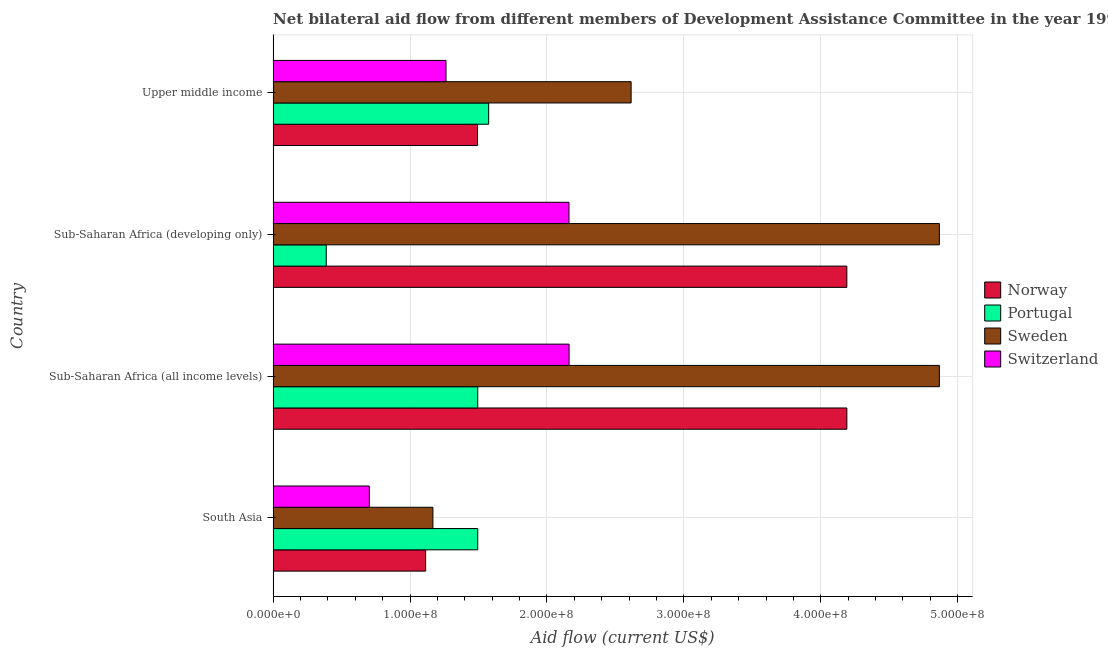Are the number of bars per tick equal to the number of legend labels?
Keep it short and to the point. Yes. What is the label of the 1st group of bars from the top?
Provide a short and direct response. Upper middle income. In how many cases, is the number of bars for a given country not equal to the number of legend labels?
Your answer should be compact. 0. What is the amount of aid given by norway in Sub-Saharan Africa (developing only)?
Keep it short and to the point. 4.19e+08. Across all countries, what is the maximum amount of aid given by sweden?
Your response must be concise. 4.87e+08. Across all countries, what is the minimum amount of aid given by norway?
Give a very brief answer. 1.11e+08. In which country was the amount of aid given by portugal maximum?
Provide a short and direct response. Upper middle income. In which country was the amount of aid given by sweden minimum?
Offer a very short reply. South Asia. What is the total amount of aid given by sweden in the graph?
Provide a short and direct response. 1.35e+09. What is the difference between the amount of aid given by switzerland in Sub-Saharan Africa (all income levels) and the amount of aid given by sweden in Upper middle income?
Offer a very short reply. -4.53e+07. What is the average amount of aid given by norway per country?
Provide a succinct answer. 2.75e+08. What is the difference between the amount of aid given by portugal and amount of aid given by norway in Sub-Saharan Africa (developing only)?
Your answer should be very brief. -3.80e+08. What is the ratio of the amount of aid given by sweden in South Asia to that in Upper middle income?
Offer a terse response. 0.45. Is the difference between the amount of aid given by switzerland in South Asia and Upper middle income greater than the difference between the amount of aid given by norway in South Asia and Upper middle income?
Offer a very short reply. No. What is the difference between the highest and the lowest amount of aid given by switzerland?
Your response must be concise. 1.46e+08. In how many countries, is the amount of aid given by switzerland greater than the average amount of aid given by switzerland taken over all countries?
Provide a short and direct response. 2. Is the sum of the amount of aid given by norway in Sub-Saharan Africa (all income levels) and Sub-Saharan Africa (developing only) greater than the maximum amount of aid given by switzerland across all countries?
Your answer should be very brief. Yes. How many countries are there in the graph?
Provide a short and direct response. 4. Are the values on the major ticks of X-axis written in scientific E-notation?
Provide a short and direct response. Yes. Does the graph contain any zero values?
Offer a very short reply. No. Does the graph contain grids?
Give a very brief answer. Yes. Where does the legend appear in the graph?
Offer a very short reply. Center right. What is the title of the graph?
Make the answer very short. Net bilateral aid flow from different members of Development Assistance Committee in the year 1996. What is the label or title of the Y-axis?
Give a very brief answer. Country. What is the Aid flow (current US$) of Norway in South Asia?
Keep it short and to the point. 1.11e+08. What is the Aid flow (current US$) in Portugal in South Asia?
Make the answer very short. 1.49e+08. What is the Aid flow (current US$) in Sweden in South Asia?
Keep it short and to the point. 1.17e+08. What is the Aid flow (current US$) of Switzerland in South Asia?
Your response must be concise. 7.03e+07. What is the Aid flow (current US$) in Norway in Sub-Saharan Africa (all income levels)?
Offer a very short reply. 4.19e+08. What is the Aid flow (current US$) of Portugal in Sub-Saharan Africa (all income levels)?
Your response must be concise. 1.49e+08. What is the Aid flow (current US$) in Sweden in Sub-Saharan Africa (all income levels)?
Your answer should be compact. 4.87e+08. What is the Aid flow (current US$) of Switzerland in Sub-Saharan Africa (all income levels)?
Keep it short and to the point. 2.16e+08. What is the Aid flow (current US$) of Norway in Sub-Saharan Africa (developing only)?
Provide a short and direct response. 4.19e+08. What is the Aid flow (current US$) in Portugal in Sub-Saharan Africa (developing only)?
Give a very brief answer. 3.88e+07. What is the Aid flow (current US$) of Sweden in Sub-Saharan Africa (developing only)?
Make the answer very short. 4.87e+08. What is the Aid flow (current US$) of Switzerland in Sub-Saharan Africa (developing only)?
Ensure brevity in your answer.  2.16e+08. What is the Aid flow (current US$) in Norway in Upper middle income?
Give a very brief answer. 1.49e+08. What is the Aid flow (current US$) of Portugal in Upper middle income?
Give a very brief answer. 1.57e+08. What is the Aid flow (current US$) in Sweden in Upper middle income?
Your answer should be compact. 2.61e+08. What is the Aid flow (current US$) of Switzerland in Upper middle income?
Give a very brief answer. 1.26e+08. Across all countries, what is the maximum Aid flow (current US$) of Norway?
Give a very brief answer. 4.19e+08. Across all countries, what is the maximum Aid flow (current US$) in Portugal?
Offer a terse response. 1.57e+08. Across all countries, what is the maximum Aid flow (current US$) of Sweden?
Keep it short and to the point. 4.87e+08. Across all countries, what is the maximum Aid flow (current US$) of Switzerland?
Offer a terse response. 2.16e+08. Across all countries, what is the minimum Aid flow (current US$) in Norway?
Provide a short and direct response. 1.11e+08. Across all countries, what is the minimum Aid flow (current US$) in Portugal?
Offer a very short reply. 3.88e+07. Across all countries, what is the minimum Aid flow (current US$) in Sweden?
Make the answer very short. 1.17e+08. Across all countries, what is the minimum Aid flow (current US$) in Switzerland?
Provide a short and direct response. 7.03e+07. What is the total Aid flow (current US$) of Norway in the graph?
Offer a terse response. 1.10e+09. What is the total Aid flow (current US$) in Portugal in the graph?
Keep it short and to the point. 4.95e+08. What is the total Aid flow (current US$) in Sweden in the graph?
Keep it short and to the point. 1.35e+09. What is the total Aid flow (current US$) of Switzerland in the graph?
Your response must be concise. 6.29e+08. What is the difference between the Aid flow (current US$) of Norway in South Asia and that in Sub-Saharan Africa (all income levels)?
Your answer should be compact. -3.08e+08. What is the difference between the Aid flow (current US$) of Sweden in South Asia and that in Sub-Saharan Africa (all income levels)?
Offer a terse response. -3.70e+08. What is the difference between the Aid flow (current US$) in Switzerland in South Asia and that in Sub-Saharan Africa (all income levels)?
Offer a very short reply. -1.46e+08. What is the difference between the Aid flow (current US$) in Norway in South Asia and that in Sub-Saharan Africa (developing only)?
Your response must be concise. -3.08e+08. What is the difference between the Aid flow (current US$) in Portugal in South Asia and that in Sub-Saharan Africa (developing only)?
Keep it short and to the point. 1.11e+08. What is the difference between the Aid flow (current US$) in Sweden in South Asia and that in Sub-Saharan Africa (developing only)?
Keep it short and to the point. -3.70e+08. What is the difference between the Aid flow (current US$) in Switzerland in South Asia and that in Sub-Saharan Africa (developing only)?
Provide a succinct answer. -1.46e+08. What is the difference between the Aid flow (current US$) of Norway in South Asia and that in Upper middle income?
Make the answer very short. -3.79e+07. What is the difference between the Aid flow (current US$) of Portugal in South Asia and that in Upper middle income?
Your answer should be very brief. -7.98e+06. What is the difference between the Aid flow (current US$) in Sweden in South Asia and that in Upper middle income?
Ensure brevity in your answer.  -1.45e+08. What is the difference between the Aid flow (current US$) of Switzerland in South Asia and that in Upper middle income?
Your answer should be compact. -5.60e+07. What is the difference between the Aid flow (current US$) in Norway in Sub-Saharan Africa (all income levels) and that in Sub-Saharan Africa (developing only)?
Provide a succinct answer. 10000. What is the difference between the Aid flow (current US$) in Portugal in Sub-Saharan Africa (all income levels) and that in Sub-Saharan Africa (developing only)?
Provide a succinct answer. 1.11e+08. What is the difference between the Aid flow (current US$) of Norway in Sub-Saharan Africa (all income levels) and that in Upper middle income?
Your answer should be compact. 2.70e+08. What is the difference between the Aid flow (current US$) of Portugal in Sub-Saharan Africa (all income levels) and that in Upper middle income?
Ensure brevity in your answer.  -7.98e+06. What is the difference between the Aid flow (current US$) in Sweden in Sub-Saharan Africa (all income levels) and that in Upper middle income?
Your response must be concise. 2.25e+08. What is the difference between the Aid flow (current US$) in Switzerland in Sub-Saharan Africa (all income levels) and that in Upper middle income?
Provide a succinct answer. 8.99e+07. What is the difference between the Aid flow (current US$) in Norway in Sub-Saharan Africa (developing only) and that in Upper middle income?
Offer a very short reply. 2.70e+08. What is the difference between the Aid flow (current US$) in Portugal in Sub-Saharan Africa (developing only) and that in Upper middle income?
Your answer should be compact. -1.19e+08. What is the difference between the Aid flow (current US$) of Sweden in Sub-Saharan Africa (developing only) and that in Upper middle income?
Provide a succinct answer. 2.25e+08. What is the difference between the Aid flow (current US$) of Switzerland in Sub-Saharan Africa (developing only) and that in Upper middle income?
Give a very brief answer. 8.98e+07. What is the difference between the Aid flow (current US$) in Norway in South Asia and the Aid flow (current US$) in Portugal in Sub-Saharan Africa (all income levels)?
Your answer should be compact. -3.81e+07. What is the difference between the Aid flow (current US$) in Norway in South Asia and the Aid flow (current US$) in Sweden in Sub-Saharan Africa (all income levels)?
Your response must be concise. -3.75e+08. What is the difference between the Aid flow (current US$) in Norway in South Asia and the Aid flow (current US$) in Switzerland in Sub-Saharan Africa (all income levels)?
Make the answer very short. -1.05e+08. What is the difference between the Aid flow (current US$) of Portugal in South Asia and the Aid flow (current US$) of Sweden in Sub-Saharan Africa (all income levels)?
Ensure brevity in your answer.  -3.37e+08. What is the difference between the Aid flow (current US$) of Portugal in South Asia and the Aid flow (current US$) of Switzerland in Sub-Saharan Africa (all income levels)?
Your answer should be very brief. -6.67e+07. What is the difference between the Aid flow (current US$) in Sweden in South Asia and the Aid flow (current US$) in Switzerland in Sub-Saharan Africa (all income levels)?
Provide a succinct answer. -9.95e+07. What is the difference between the Aid flow (current US$) of Norway in South Asia and the Aid flow (current US$) of Portugal in Sub-Saharan Africa (developing only)?
Ensure brevity in your answer.  7.26e+07. What is the difference between the Aid flow (current US$) of Norway in South Asia and the Aid flow (current US$) of Sweden in Sub-Saharan Africa (developing only)?
Your answer should be compact. -3.75e+08. What is the difference between the Aid flow (current US$) in Norway in South Asia and the Aid flow (current US$) in Switzerland in Sub-Saharan Africa (developing only)?
Offer a terse response. -1.05e+08. What is the difference between the Aid flow (current US$) of Portugal in South Asia and the Aid flow (current US$) of Sweden in Sub-Saharan Africa (developing only)?
Your answer should be compact. -3.37e+08. What is the difference between the Aid flow (current US$) of Portugal in South Asia and the Aid flow (current US$) of Switzerland in Sub-Saharan Africa (developing only)?
Offer a terse response. -6.66e+07. What is the difference between the Aid flow (current US$) in Sweden in South Asia and the Aid flow (current US$) in Switzerland in Sub-Saharan Africa (developing only)?
Offer a terse response. -9.94e+07. What is the difference between the Aid flow (current US$) in Norway in South Asia and the Aid flow (current US$) in Portugal in Upper middle income?
Make the answer very short. -4.60e+07. What is the difference between the Aid flow (current US$) in Norway in South Asia and the Aid flow (current US$) in Sweden in Upper middle income?
Offer a terse response. -1.50e+08. What is the difference between the Aid flow (current US$) in Norway in South Asia and the Aid flow (current US$) in Switzerland in Upper middle income?
Offer a very short reply. -1.49e+07. What is the difference between the Aid flow (current US$) in Portugal in South Asia and the Aid flow (current US$) in Sweden in Upper middle income?
Ensure brevity in your answer.  -1.12e+08. What is the difference between the Aid flow (current US$) in Portugal in South Asia and the Aid flow (current US$) in Switzerland in Upper middle income?
Offer a very short reply. 2.32e+07. What is the difference between the Aid flow (current US$) of Sweden in South Asia and the Aid flow (current US$) of Switzerland in Upper middle income?
Your answer should be compact. -9.58e+06. What is the difference between the Aid flow (current US$) in Norway in Sub-Saharan Africa (all income levels) and the Aid flow (current US$) in Portugal in Sub-Saharan Africa (developing only)?
Give a very brief answer. 3.80e+08. What is the difference between the Aid flow (current US$) in Norway in Sub-Saharan Africa (all income levels) and the Aid flow (current US$) in Sweden in Sub-Saharan Africa (developing only)?
Ensure brevity in your answer.  -6.76e+07. What is the difference between the Aid flow (current US$) of Norway in Sub-Saharan Africa (all income levels) and the Aid flow (current US$) of Switzerland in Sub-Saharan Africa (developing only)?
Your answer should be compact. 2.03e+08. What is the difference between the Aid flow (current US$) in Portugal in Sub-Saharan Africa (all income levels) and the Aid flow (current US$) in Sweden in Sub-Saharan Africa (developing only)?
Make the answer very short. -3.37e+08. What is the difference between the Aid flow (current US$) of Portugal in Sub-Saharan Africa (all income levels) and the Aid flow (current US$) of Switzerland in Sub-Saharan Africa (developing only)?
Your response must be concise. -6.66e+07. What is the difference between the Aid flow (current US$) of Sweden in Sub-Saharan Africa (all income levels) and the Aid flow (current US$) of Switzerland in Sub-Saharan Africa (developing only)?
Make the answer very short. 2.71e+08. What is the difference between the Aid flow (current US$) of Norway in Sub-Saharan Africa (all income levels) and the Aid flow (current US$) of Portugal in Upper middle income?
Your answer should be very brief. 2.62e+08. What is the difference between the Aid flow (current US$) of Norway in Sub-Saharan Africa (all income levels) and the Aid flow (current US$) of Sweden in Upper middle income?
Ensure brevity in your answer.  1.58e+08. What is the difference between the Aid flow (current US$) in Norway in Sub-Saharan Africa (all income levels) and the Aid flow (current US$) in Switzerland in Upper middle income?
Provide a succinct answer. 2.93e+08. What is the difference between the Aid flow (current US$) of Portugal in Sub-Saharan Africa (all income levels) and the Aid flow (current US$) of Sweden in Upper middle income?
Provide a short and direct response. -1.12e+08. What is the difference between the Aid flow (current US$) of Portugal in Sub-Saharan Africa (all income levels) and the Aid flow (current US$) of Switzerland in Upper middle income?
Your answer should be compact. 2.32e+07. What is the difference between the Aid flow (current US$) in Sweden in Sub-Saharan Africa (all income levels) and the Aid flow (current US$) in Switzerland in Upper middle income?
Offer a terse response. 3.60e+08. What is the difference between the Aid flow (current US$) in Norway in Sub-Saharan Africa (developing only) and the Aid flow (current US$) in Portugal in Upper middle income?
Offer a very short reply. 2.62e+08. What is the difference between the Aid flow (current US$) in Norway in Sub-Saharan Africa (developing only) and the Aid flow (current US$) in Sweden in Upper middle income?
Your response must be concise. 1.58e+08. What is the difference between the Aid flow (current US$) in Norway in Sub-Saharan Africa (developing only) and the Aid flow (current US$) in Switzerland in Upper middle income?
Keep it short and to the point. 2.93e+08. What is the difference between the Aid flow (current US$) of Portugal in Sub-Saharan Africa (developing only) and the Aid flow (current US$) of Sweden in Upper middle income?
Provide a succinct answer. -2.23e+08. What is the difference between the Aid flow (current US$) of Portugal in Sub-Saharan Africa (developing only) and the Aid flow (current US$) of Switzerland in Upper middle income?
Provide a succinct answer. -8.75e+07. What is the difference between the Aid flow (current US$) in Sweden in Sub-Saharan Africa (developing only) and the Aid flow (current US$) in Switzerland in Upper middle income?
Your answer should be very brief. 3.60e+08. What is the average Aid flow (current US$) of Norway per country?
Keep it short and to the point. 2.75e+08. What is the average Aid flow (current US$) in Portugal per country?
Ensure brevity in your answer.  1.24e+08. What is the average Aid flow (current US$) of Sweden per country?
Keep it short and to the point. 3.38e+08. What is the average Aid flow (current US$) of Switzerland per country?
Give a very brief answer. 1.57e+08. What is the difference between the Aid flow (current US$) of Norway and Aid flow (current US$) of Portugal in South Asia?
Keep it short and to the point. -3.81e+07. What is the difference between the Aid flow (current US$) of Norway and Aid flow (current US$) of Sweden in South Asia?
Give a very brief answer. -5.31e+06. What is the difference between the Aid flow (current US$) of Norway and Aid flow (current US$) of Switzerland in South Asia?
Offer a very short reply. 4.11e+07. What is the difference between the Aid flow (current US$) in Portugal and Aid flow (current US$) in Sweden in South Asia?
Ensure brevity in your answer.  3.28e+07. What is the difference between the Aid flow (current US$) of Portugal and Aid flow (current US$) of Switzerland in South Asia?
Provide a succinct answer. 7.92e+07. What is the difference between the Aid flow (current US$) in Sweden and Aid flow (current US$) in Switzerland in South Asia?
Offer a very short reply. 4.64e+07. What is the difference between the Aid flow (current US$) of Norway and Aid flow (current US$) of Portugal in Sub-Saharan Africa (all income levels)?
Your answer should be very brief. 2.70e+08. What is the difference between the Aid flow (current US$) of Norway and Aid flow (current US$) of Sweden in Sub-Saharan Africa (all income levels)?
Your answer should be very brief. -6.76e+07. What is the difference between the Aid flow (current US$) of Norway and Aid flow (current US$) of Switzerland in Sub-Saharan Africa (all income levels)?
Offer a very short reply. 2.03e+08. What is the difference between the Aid flow (current US$) of Portugal and Aid flow (current US$) of Sweden in Sub-Saharan Africa (all income levels)?
Give a very brief answer. -3.37e+08. What is the difference between the Aid flow (current US$) of Portugal and Aid flow (current US$) of Switzerland in Sub-Saharan Africa (all income levels)?
Your answer should be very brief. -6.67e+07. What is the difference between the Aid flow (current US$) in Sweden and Aid flow (current US$) in Switzerland in Sub-Saharan Africa (all income levels)?
Offer a very short reply. 2.70e+08. What is the difference between the Aid flow (current US$) of Norway and Aid flow (current US$) of Portugal in Sub-Saharan Africa (developing only)?
Give a very brief answer. 3.80e+08. What is the difference between the Aid flow (current US$) in Norway and Aid flow (current US$) in Sweden in Sub-Saharan Africa (developing only)?
Give a very brief answer. -6.76e+07. What is the difference between the Aid flow (current US$) in Norway and Aid flow (current US$) in Switzerland in Sub-Saharan Africa (developing only)?
Your answer should be very brief. 2.03e+08. What is the difference between the Aid flow (current US$) of Portugal and Aid flow (current US$) of Sweden in Sub-Saharan Africa (developing only)?
Give a very brief answer. -4.48e+08. What is the difference between the Aid flow (current US$) of Portugal and Aid flow (current US$) of Switzerland in Sub-Saharan Africa (developing only)?
Give a very brief answer. -1.77e+08. What is the difference between the Aid flow (current US$) in Sweden and Aid flow (current US$) in Switzerland in Sub-Saharan Africa (developing only)?
Provide a succinct answer. 2.71e+08. What is the difference between the Aid flow (current US$) in Norway and Aid flow (current US$) in Portugal in Upper middle income?
Offer a terse response. -8.14e+06. What is the difference between the Aid flow (current US$) of Norway and Aid flow (current US$) of Sweden in Upper middle income?
Offer a very short reply. -1.12e+08. What is the difference between the Aid flow (current US$) in Norway and Aid flow (current US$) in Switzerland in Upper middle income?
Your response must be concise. 2.30e+07. What is the difference between the Aid flow (current US$) in Portugal and Aid flow (current US$) in Sweden in Upper middle income?
Your answer should be very brief. -1.04e+08. What is the difference between the Aid flow (current US$) of Portugal and Aid flow (current US$) of Switzerland in Upper middle income?
Your answer should be compact. 3.12e+07. What is the difference between the Aid flow (current US$) in Sweden and Aid flow (current US$) in Switzerland in Upper middle income?
Offer a very short reply. 1.35e+08. What is the ratio of the Aid flow (current US$) in Norway in South Asia to that in Sub-Saharan Africa (all income levels)?
Make the answer very short. 0.27. What is the ratio of the Aid flow (current US$) in Sweden in South Asia to that in Sub-Saharan Africa (all income levels)?
Give a very brief answer. 0.24. What is the ratio of the Aid flow (current US$) of Switzerland in South Asia to that in Sub-Saharan Africa (all income levels)?
Offer a very short reply. 0.33. What is the ratio of the Aid flow (current US$) of Norway in South Asia to that in Sub-Saharan Africa (developing only)?
Your response must be concise. 0.27. What is the ratio of the Aid flow (current US$) of Portugal in South Asia to that in Sub-Saharan Africa (developing only)?
Offer a very short reply. 3.85. What is the ratio of the Aid flow (current US$) in Sweden in South Asia to that in Sub-Saharan Africa (developing only)?
Your response must be concise. 0.24. What is the ratio of the Aid flow (current US$) of Switzerland in South Asia to that in Sub-Saharan Africa (developing only)?
Your answer should be compact. 0.33. What is the ratio of the Aid flow (current US$) in Norway in South Asia to that in Upper middle income?
Offer a very short reply. 0.75. What is the ratio of the Aid flow (current US$) in Portugal in South Asia to that in Upper middle income?
Provide a short and direct response. 0.95. What is the ratio of the Aid flow (current US$) of Sweden in South Asia to that in Upper middle income?
Your answer should be very brief. 0.45. What is the ratio of the Aid flow (current US$) of Switzerland in South Asia to that in Upper middle income?
Offer a very short reply. 0.56. What is the ratio of the Aid flow (current US$) of Norway in Sub-Saharan Africa (all income levels) to that in Sub-Saharan Africa (developing only)?
Keep it short and to the point. 1. What is the ratio of the Aid flow (current US$) in Portugal in Sub-Saharan Africa (all income levels) to that in Sub-Saharan Africa (developing only)?
Provide a succinct answer. 3.85. What is the ratio of the Aid flow (current US$) in Norway in Sub-Saharan Africa (all income levels) to that in Upper middle income?
Your answer should be very brief. 2.81. What is the ratio of the Aid flow (current US$) in Portugal in Sub-Saharan Africa (all income levels) to that in Upper middle income?
Ensure brevity in your answer.  0.95. What is the ratio of the Aid flow (current US$) in Sweden in Sub-Saharan Africa (all income levels) to that in Upper middle income?
Make the answer very short. 1.86. What is the ratio of the Aid flow (current US$) of Switzerland in Sub-Saharan Africa (all income levels) to that in Upper middle income?
Offer a very short reply. 1.71. What is the ratio of the Aid flow (current US$) of Norway in Sub-Saharan Africa (developing only) to that in Upper middle income?
Offer a very short reply. 2.81. What is the ratio of the Aid flow (current US$) of Portugal in Sub-Saharan Africa (developing only) to that in Upper middle income?
Give a very brief answer. 0.25. What is the ratio of the Aid flow (current US$) of Sweden in Sub-Saharan Africa (developing only) to that in Upper middle income?
Offer a very short reply. 1.86. What is the ratio of the Aid flow (current US$) in Switzerland in Sub-Saharan Africa (developing only) to that in Upper middle income?
Ensure brevity in your answer.  1.71. What is the difference between the highest and the second highest Aid flow (current US$) in Norway?
Your answer should be very brief. 10000. What is the difference between the highest and the second highest Aid flow (current US$) of Portugal?
Give a very brief answer. 7.98e+06. What is the difference between the highest and the second highest Aid flow (current US$) of Switzerland?
Offer a terse response. 6.00e+04. What is the difference between the highest and the lowest Aid flow (current US$) of Norway?
Make the answer very short. 3.08e+08. What is the difference between the highest and the lowest Aid flow (current US$) in Portugal?
Your answer should be very brief. 1.19e+08. What is the difference between the highest and the lowest Aid flow (current US$) in Sweden?
Give a very brief answer. 3.70e+08. What is the difference between the highest and the lowest Aid flow (current US$) of Switzerland?
Give a very brief answer. 1.46e+08. 